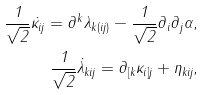Convert formula to latex. <formula><loc_0><loc_0><loc_500><loc_500>\frac { 1 } { \sqrt { 2 } } \dot { \kappa } _ { i j } = \partial ^ { k } \lambda _ { k ( i j ) } - \frac { 1 } { \sqrt { 2 } } \partial _ { i } \partial _ { j } \alpha , \\ \frac { 1 } { \sqrt { 2 } } \dot { \lambda } _ { k i j } = \partial _ { [ k } \kappa _ { i ] j } + \eta _ { k i j } ,</formula> 